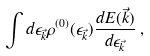<formula> <loc_0><loc_0><loc_500><loc_500>\int d \epsilon _ { \vec { k } } \rho ^ { ( 0 ) } ( \epsilon _ { \vec { k } } ) \frac { d E ( { \vec { k } } ) } { d \epsilon _ { \vec { k } } } \, ,</formula> 